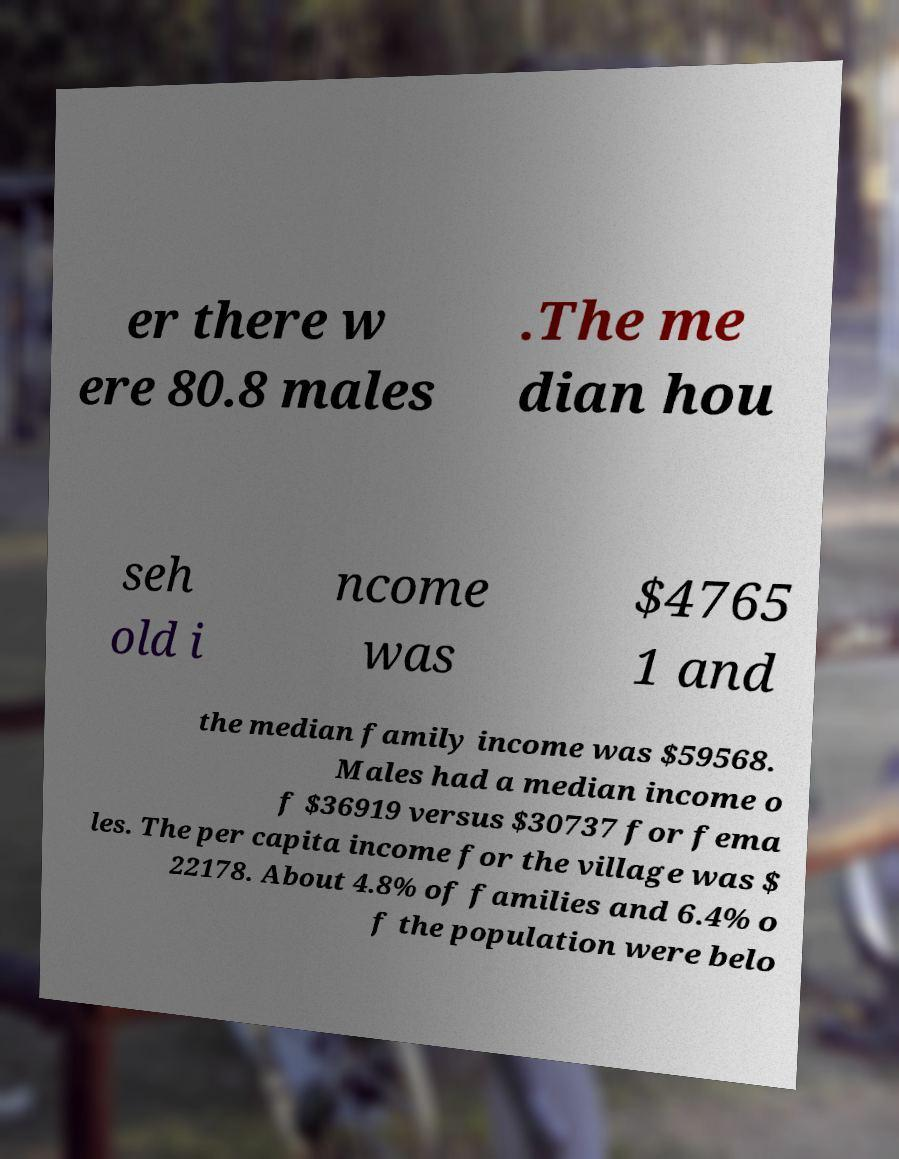Could you extract and type out the text from this image? er there w ere 80.8 males .The me dian hou seh old i ncome was $4765 1 and the median family income was $59568. Males had a median income o f $36919 versus $30737 for fema les. The per capita income for the village was $ 22178. About 4.8% of families and 6.4% o f the population were belo 